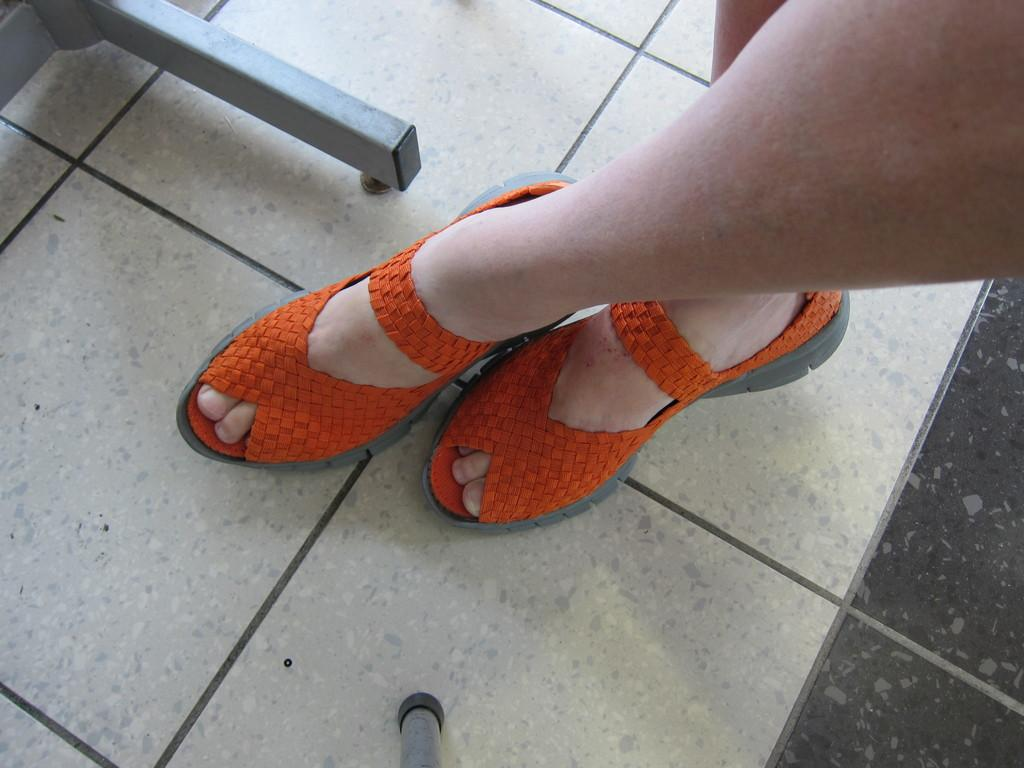What part of a person can be seen in the image? There are legs of a person visible in the image. What type of footwear is the person wearing? The person is wearing shoes. What can be seen in the background of the image? There are metal poles in the background of the image. Where is the coal being stored in the image? There is no coal present in the image. What type of basin is being used by the person in the image? There is no basin visible in the image. 